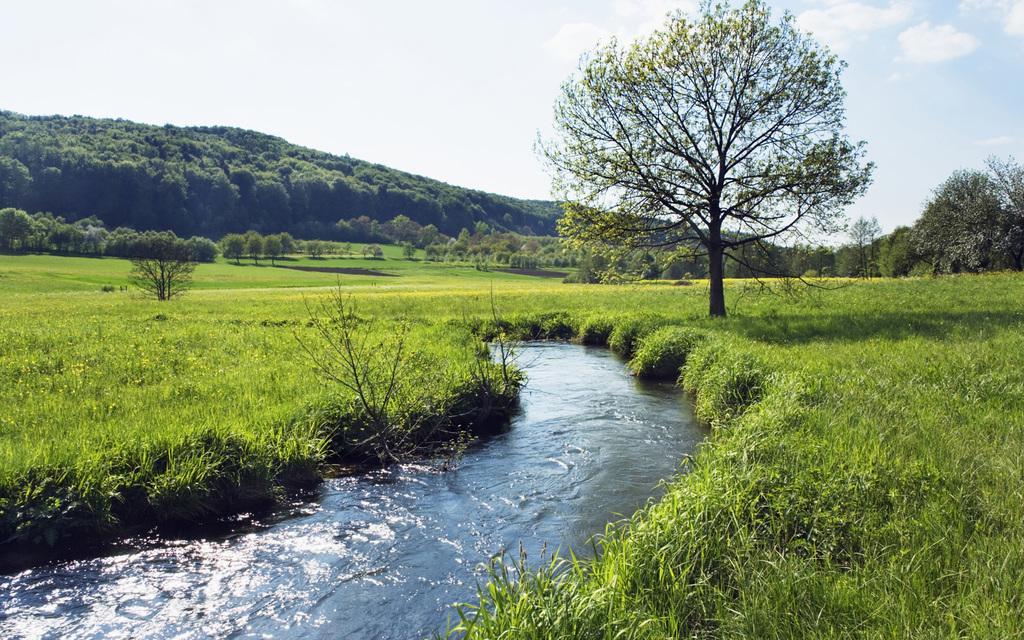Can you describe this image briefly? In this picture I can see water, there is grass, there are trees, there is a hill, and in the background there is sky. 